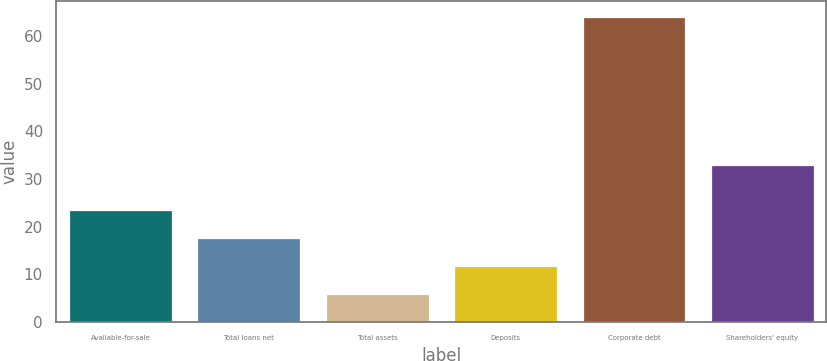<chart> <loc_0><loc_0><loc_500><loc_500><bar_chart><fcel>Available-for-sale<fcel>Total loans net<fcel>Total assets<fcel>Deposits<fcel>Corporate debt<fcel>Shareholders' equity<nl><fcel>23.4<fcel>17.6<fcel>6<fcel>11.8<fcel>64<fcel>33<nl></chart> 